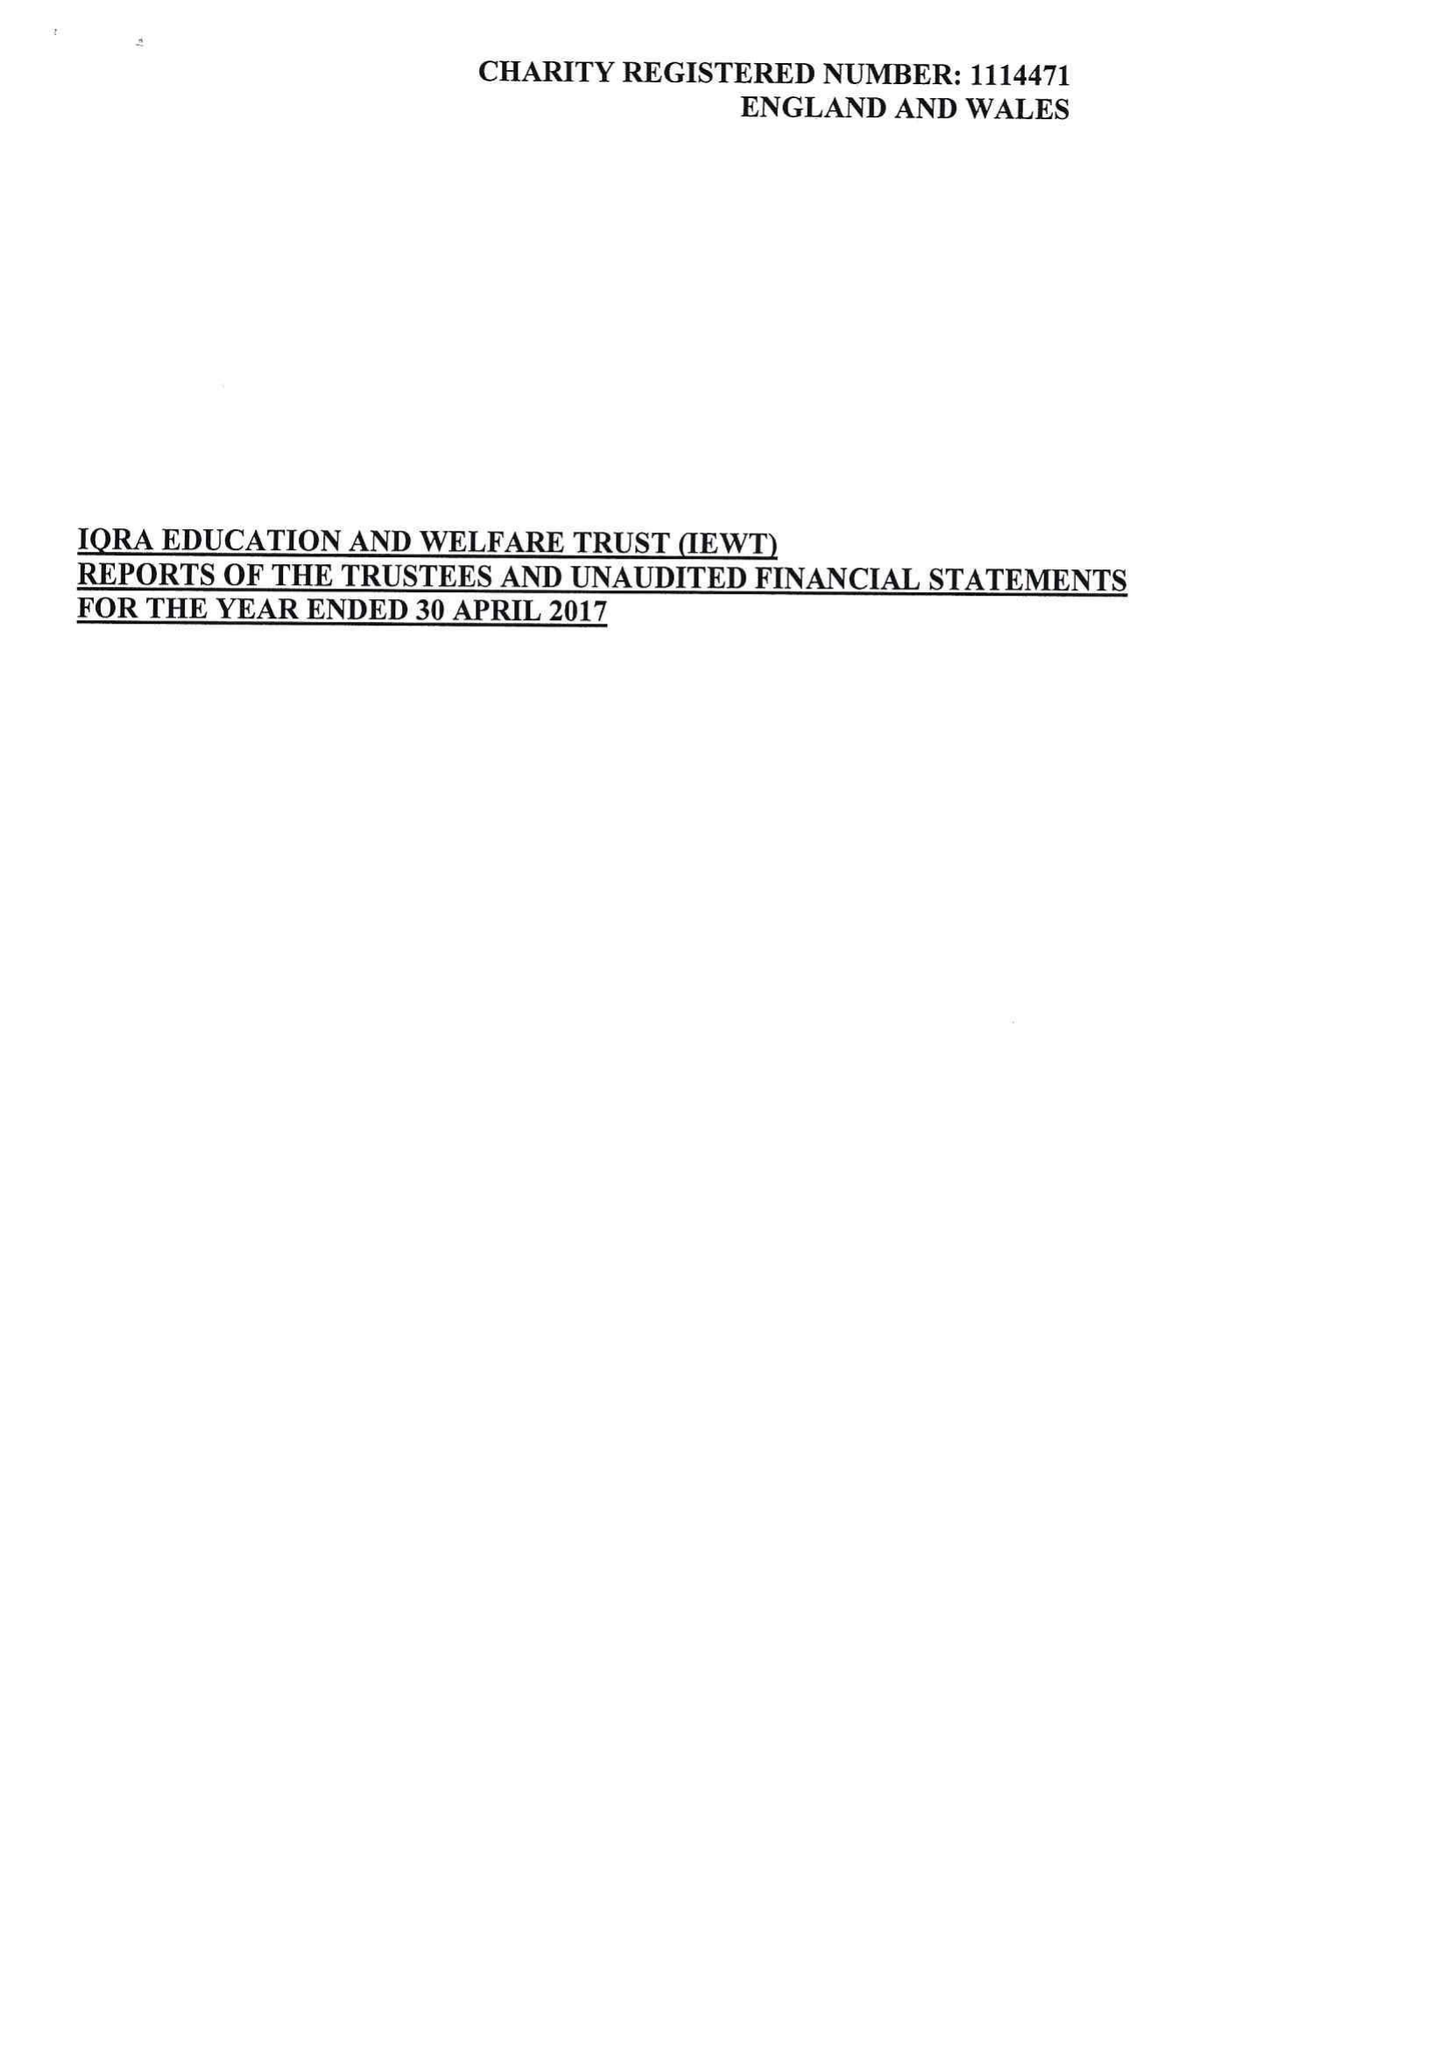What is the value for the charity_number?
Answer the question using a single word or phrase. 1114471 